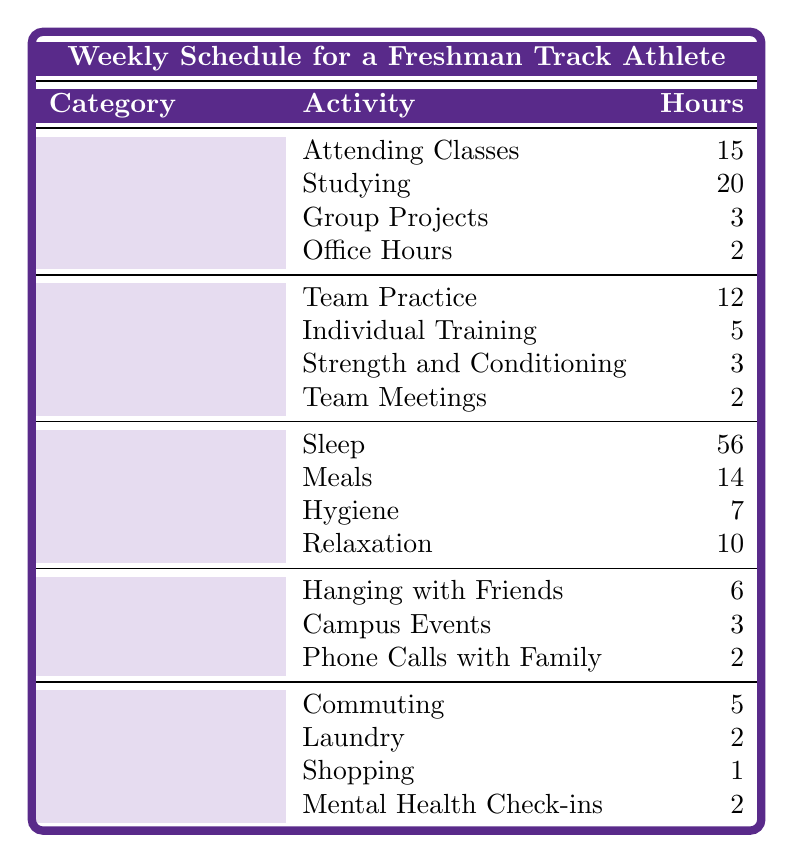What is the total number of hours spent on academic activities? The total hours for academic activities are found by adding all the hours listed: 15 (Attending Classes) + 20 (Studying) + 3 (Group Projects) + 2 (Office Hours) = 40 hours.
Answer: 40 How many hours are dedicated to track and field activities in total? To find the total hours for track and field activities, add up the hours: 12 (Team Practice) + 5 (Individual Training) + 3 (Strength and Conditioning) + 2 (Team Meetings) = 22 hours.
Answer: 22 What activity takes the most time under personal care? The activity with the most hours under personal care is Sleep, with 56 hours allocated.
Answer: Sleep Is the time spent on relaxation more than the time spent on hygiene? Comparing the hours, Relaxation has 10 hours and Hygiene has 7 hours. Since 10 is greater than 7, the statement is true.
Answer: Yes What percentage of total weekly hours (168 hours) is spent on studying? To find the percentage, divide the hours spent on studying (20) by total weekly hours (168) and multiply by 100: (20/168) * 100 = 11.9%.
Answer: 11.9% How many more hours are spent on sleep than on meals? The hours for sleep is 56 and for meals is 14. The difference is calculated by subtracting: 56 - 14 = 42 hours more spent on sleep.
Answer: 42 What is the total time allocated for social activities? The total hours for social activities are calculated by summing: 6 (Hanging with Friends) + 3 (Campus Events) + 2 (Phone Calls with Family) = 11 hours.
Answer: 11 If commuting takes 5 hours, what is the combined time for laundry and shopping? Laundry takes 2 hours and shopping takes 1 hour. Adding these gives: 2 + 1 = 3 hours for laundry and shopping combined.
Answer: 3 Is the time spent in team meetings more than the time spent attending office hours? Team Meetings take 2 hours while Office Hours also take 2 hours. Since they are equal, the statement is false.
Answer: No What is the total number of hours spent on personal care activities? The total hours for personal care is calculated as: 56 (Sleep) + 14 (Meals) + 7 (Hygiene) + 10 (Relaxation) = 87 hours.
Answer: 87 